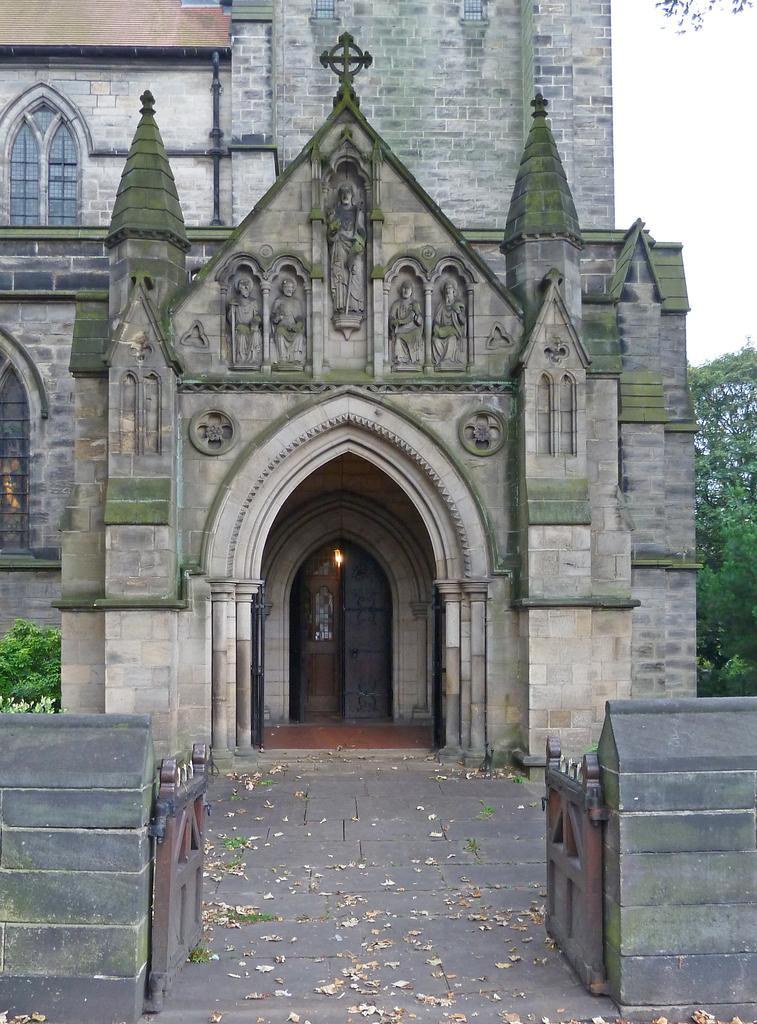Please provide a concise description of this image. In this image I can see the building, windows, gate and few trees. The sky is in white color. 